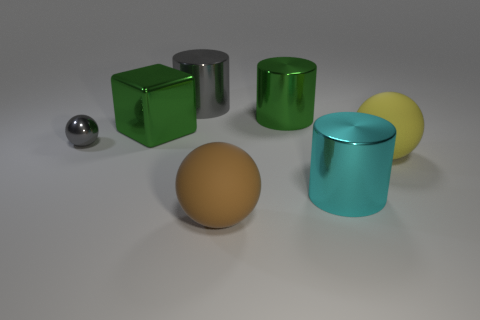There is a brown thing; are there any large metal cylinders behind it?
Your response must be concise. Yes. How many yellow spheres are to the left of the green metallic object behind the metallic block?
Your answer should be very brief. 0. There is a brown thing that is the same size as the yellow ball; what material is it?
Offer a terse response. Rubber. How many other things are there of the same material as the large brown object?
Offer a very short reply. 1. There is a brown ball; how many big green things are on the right side of it?
Offer a very short reply. 1. What number of cylinders are large green metallic objects or shiny things?
Your answer should be very brief. 3. What size is the thing that is in front of the green shiny cylinder and behind the small gray ball?
Offer a terse response. Large. Is the cyan thing made of the same material as the big cylinder that is on the left side of the big brown thing?
Your response must be concise. Yes. How many objects are either cylinders that are behind the gray ball or gray metallic balls?
Offer a very short reply. 3. What is the shape of the shiny object that is on the left side of the large green metal cylinder and to the right of the large green metal cube?
Provide a succinct answer. Cylinder. 